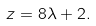<formula> <loc_0><loc_0><loc_500><loc_500>z = 8 \lambda + 2 .</formula> 